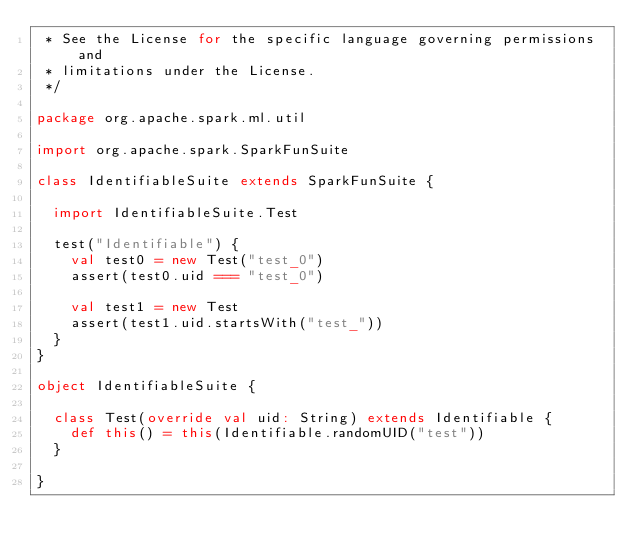<code> <loc_0><loc_0><loc_500><loc_500><_Scala_> * See the License for the specific language governing permissions and
 * limitations under the License.
 */

package org.apache.spark.ml.util

import org.apache.spark.SparkFunSuite

class IdentifiableSuite extends SparkFunSuite {

  import IdentifiableSuite.Test

  test("Identifiable") {
    val test0 = new Test("test_0")
    assert(test0.uid === "test_0")

    val test1 = new Test
    assert(test1.uid.startsWith("test_"))
  }
}

object IdentifiableSuite {

  class Test(override val uid: String) extends Identifiable {
    def this() = this(Identifiable.randomUID("test"))
  }

}
</code> 